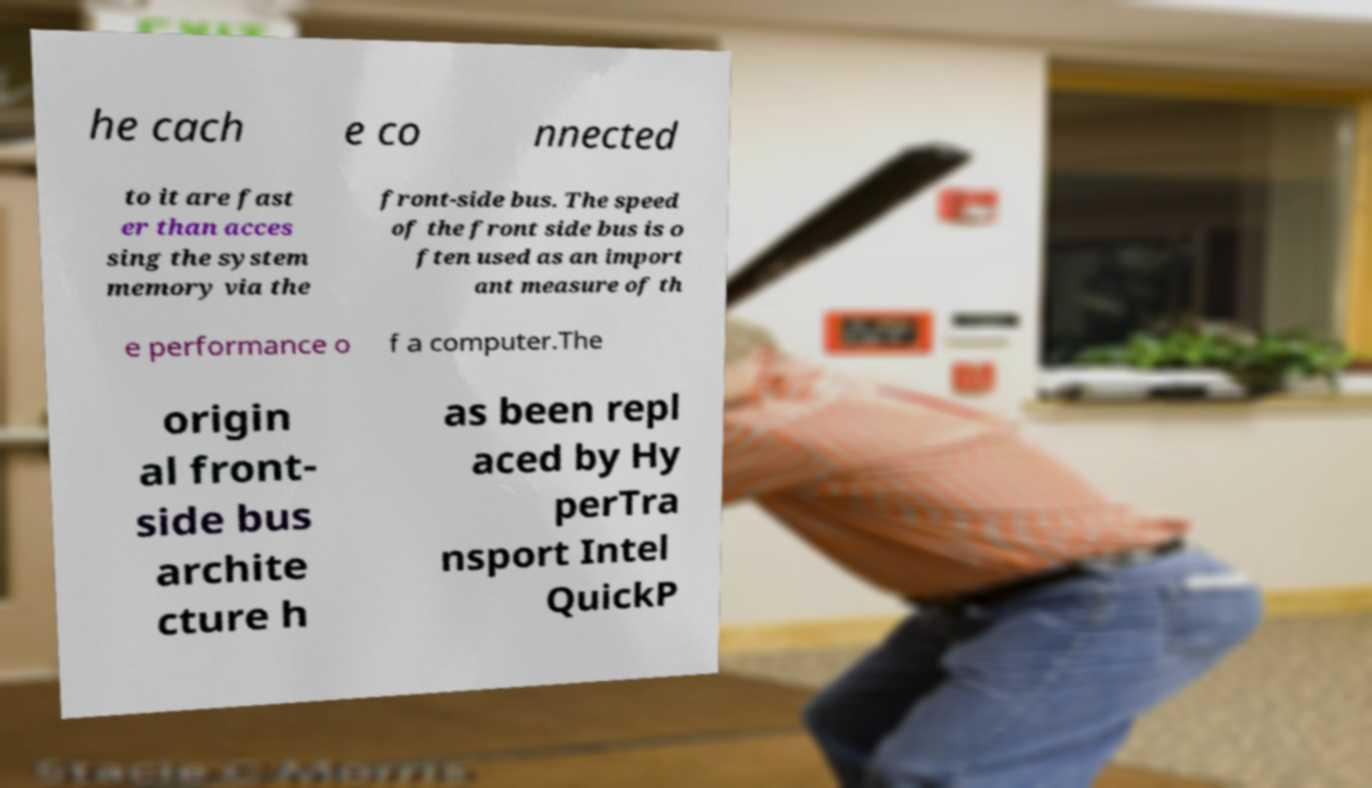Could you extract and type out the text from this image? he cach e co nnected to it are fast er than acces sing the system memory via the front-side bus. The speed of the front side bus is o ften used as an import ant measure of th e performance o f a computer.The origin al front- side bus archite cture h as been repl aced by Hy perTra nsport Intel QuickP 